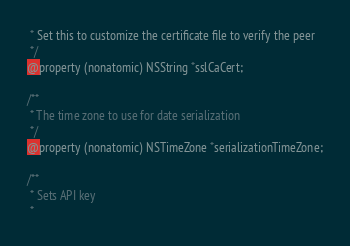Convert code to text. <code><loc_0><loc_0><loc_500><loc_500><_C_> * Set this to customize the certificate file to verify the peer
 */
@property (nonatomic) NSString *sslCaCert;

/**
 * The time zone to use for date serialization
 */
@property (nonatomic) NSTimeZone *serializationTimeZone;

/**
 * Sets API key
 *</code> 